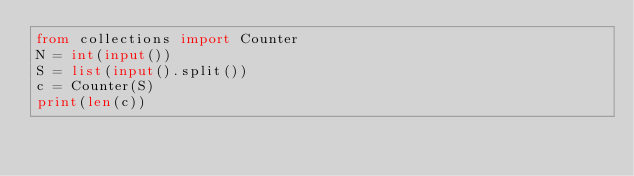<code> <loc_0><loc_0><loc_500><loc_500><_Python_>from collections import Counter
N = int(input())
S = list(input().split())
c = Counter(S)
print(len(c))</code> 